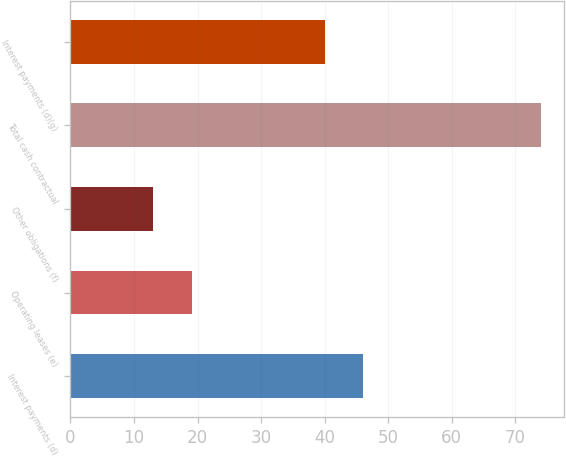Convert chart to OTSL. <chart><loc_0><loc_0><loc_500><loc_500><bar_chart><fcel>Interest payments (d)<fcel>Operating leases (e)<fcel>Other obligations (f)<fcel>Total cash contractual<fcel>Interest payments (d)(g)<nl><fcel>46.1<fcel>19.1<fcel>13<fcel>74<fcel>40<nl></chart> 